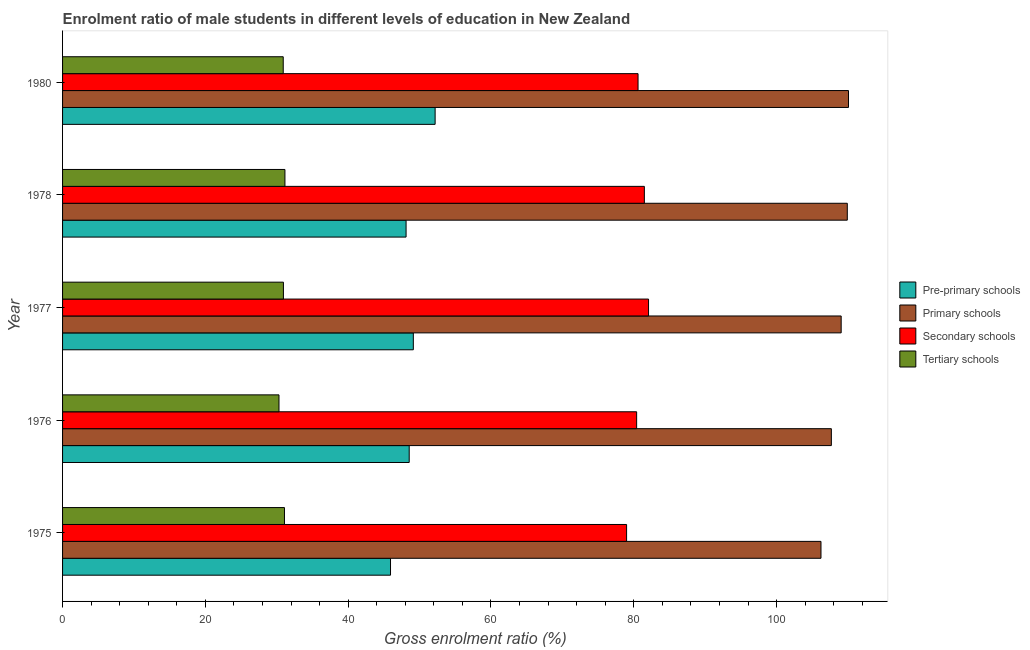How many different coloured bars are there?
Provide a short and direct response. 4. Are the number of bars per tick equal to the number of legend labels?
Make the answer very short. Yes. Are the number of bars on each tick of the Y-axis equal?
Provide a succinct answer. Yes. What is the label of the 2nd group of bars from the top?
Make the answer very short. 1978. In how many cases, is the number of bars for a given year not equal to the number of legend labels?
Keep it short and to the point. 0. What is the gross enrolment ratio(female) in secondary schools in 1976?
Provide a short and direct response. 80.4. Across all years, what is the maximum gross enrolment ratio(female) in tertiary schools?
Provide a short and direct response. 31.14. Across all years, what is the minimum gross enrolment ratio(female) in pre-primary schools?
Provide a succinct answer. 45.93. In which year was the gross enrolment ratio(female) in primary schools minimum?
Give a very brief answer. 1975. What is the total gross enrolment ratio(female) in tertiary schools in the graph?
Offer a very short reply. 154.37. What is the difference between the gross enrolment ratio(female) in tertiary schools in 1976 and that in 1977?
Your response must be concise. -0.62. What is the difference between the gross enrolment ratio(female) in primary schools in 1978 and the gross enrolment ratio(female) in tertiary schools in 1975?
Ensure brevity in your answer.  78.83. What is the average gross enrolment ratio(female) in secondary schools per year?
Give a very brief answer. 80.71. In the year 1977, what is the difference between the gross enrolment ratio(female) in pre-primary schools and gross enrolment ratio(female) in tertiary schools?
Provide a short and direct response. 18.19. Is the gross enrolment ratio(female) in secondary schools in 1977 less than that in 1978?
Your answer should be compact. No. Is the difference between the gross enrolment ratio(female) in tertiary schools in 1978 and 1980 greater than the difference between the gross enrolment ratio(female) in secondary schools in 1978 and 1980?
Offer a terse response. No. What is the difference between the highest and the second highest gross enrolment ratio(female) in pre-primary schools?
Keep it short and to the point. 3.05. What is the difference between the highest and the lowest gross enrolment ratio(female) in pre-primary schools?
Give a very brief answer. 6.25. What does the 1st bar from the top in 1980 represents?
Give a very brief answer. Tertiary schools. What does the 1st bar from the bottom in 1975 represents?
Offer a very short reply. Pre-primary schools. How many years are there in the graph?
Your answer should be very brief. 5. What is the difference between two consecutive major ticks on the X-axis?
Keep it short and to the point. 20. Are the values on the major ticks of X-axis written in scientific E-notation?
Your answer should be compact. No. Where does the legend appear in the graph?
Your response must be concise. Center right. What is the title of the graph?
Make the answer very short. Enrolment ratio of male students in different levels of education in New Zealand. Does "Social equity" appear as one of the legend labels in the graph?
Your answer should be compact. No. What is the label or title of the X-axis?
Provide a succinct answer. Gross enrolment ratio (%). What is the label or title of the Y-axis?
Provide a succinct answer. Year. What is the Gross enrolment ratio (%) in Pre-primary schools in 1975?
Offer a very short reply. 45.93. What is the Gross enrolment ratio (%) of Primary schools in 1975?
Provide a succinct answer. 106.22. What is the Gross enrolment ratio (%) of Secondary schools in 1975?
Provide a short and direct response. 79. What is the Gross enrolment ratio (%) of Tertiary schools in 1975?
Ensure brevity in your answer.  31.08. What is the Gross enrolment ratio (%) in Pre-primary schools in 1976?
Your answer should be very brief. 48.55. What is the Gross enrolment ratio (%) of Primary schools in 1976?
Keep it short and to the point. 107.68. What is the Gross enrolment ratio (%) in Secondary schools in 1976?
Give a very brief answer. 80.4. What is the Gross enrolment ratio (%) of Tertiary schools in 1976?
Offer a very short reply. 30.31. What is the Gross enrolment ratio (%) of Pre-primary schools in 1977?
Keep it short and to the point. 49.13. What is the Gross enrolment ratio (%) of Primary schools in 1977?
Offer a terse response. 109.05. What is the Gross enrolment ratio (%) of Secondary schools in 1977?
Offer a very short reply. 82.07. What is the Gross enrolment ratio (%) of Tertiary schools in 1977?
Ensure brevity in your answer.  30.93. What is the Gross enrolment ratio (%) of Pre-primary schools in 1978?
Offer a very short reply. 48.11. What is the Gross enrolment ratio (%) of Primary schools in 1978?
Offer a very short reply. 109.91. What is the Gross enrolment ratio (%) in Secondary schools in 1978?
Offer a terse response. 81.48. What is the Gross enrolment ratio (%) in Tertiary schools in 1978?
Offer a very short reply. 31.14. What is the Gross enrolment ratio (%) in Pre-primary schools in 1980?
Keep it short and to the point. 52.18. What is the Gross enrolment ratio (%) in Primary schools in 1980?
Keep it short and to the point. 110.08. What is the Gross enrolment ratio (%) in Secondary schools in 1980?
Make the answer very short. 80.6. What is the Gross enrolment ratio (%) in Tertiary schools in 1980?
Keep it short and to the point. 30.91. Across all years, what is the maximum Gross enrolment ratio (%) in Pre-primary schools?
Offer a very short reply. 52.18. Across all years, what is the maximum Gross enrolment ratio (%) of Primary schools?
Your response must be concise. 110.08. Across all years, what is the maximum Gross enrolment ratio (%) of Secondary schools?
Provide a succinct answer. 82.07. Across all years, what is the maximum Gross enrolment ratio (%) of Tertiary schools?
Ensure brevity in your answer.  31.14. Across all years, what is the minimum Gross enrolment ratio (%) of Pre-primary schools?
Your answer should be very brief. 45.93. Across all years, what is the minimum Gross enrolment ratio (%) of Primary schools?
Ensure brevity in your answer.  106.22. Across all years, what is the minimum Gross enrolment ratio (%) in Secondary schools?
Your response must be concise. 79. Across all years, what is the minimum Gross enrolment ratio (%) of Tertiary schools?
Keep it short and to the point. 30.31. What is the total Gross enrolment ratio (%) of Pre-primary schools in the graph?
Offer a terse response. 243.9. What is the total Gross enrolment ratio (%) of Primary schools in the graph?
Provide a short and direct response. 542.94. What is the total Gross enrolment ratio (%) in Secondary schools in the graph?
Ensure brevity in your answer.  403.56. What is the total Gross enrolment ratio (%) in Tertiary schools in the graph?
Your answer should be very brief. 154.37. What is the difference between the Gross enrolment ratio (%) of Pre-primary schools in 1975 and that in 1976?
Offer a very short reply. -2.62. What is the difference between the Gross enrolment ratio (%) of Primary schools in 1975 and that in 1976?
Give a very brief answer. -1.45. What is the difference between the Gross enrolment ratio (%) in Secondary schools in 1975 and that in 1976?
Provide a succinct answer. -1.41. What is the difference between the Gross enrolment ratio (%) in Tertiary schools in 1975 and that in 1976?
Ensure brevity in your answer.  0.77. What is the difference between the Gross enrolment ratio (%) in Pre-primary schools in 1975 and that in 1977?
Ensure brevity in your answer.  -3.19. What is the difference between the Gross enrolment ratio (%) of Primary schools in 1975 and that in 1977?
Your response must be concise. -2.83. What is the difference between the Gross enrolment ratio (%) of Secondary schools in 1975 and that in 1977?
Offer a terse response. -3.07. What is the difference between the Gross enrolment ratio (%) of Tertiary schools in 1975 and that in 1977?
Your answer should be very brief. 0.15. What is the difference between the Gross enrolment ratio (%) of Pre-primary schools in 1975 and that in 1978?
Give a very brief answer. -2.18. What is the difference between the Gross enrolment ratio (%) of Primary schools in 1975 and that in 1978?
Give a very brief answer. -3.69. What is the difference between the Gross enrolment ratio (%) in Secondary schools in 1975 and that in 1978?
Make the answer very short. -2.49. What is the difference between the Gross enrolment ratio (%) of Tertiary schools in 1975 and that in 1978?
Provide a short and direct response. -0.06. What is the difference between the Gross enrolment ratio (%) in Pre-primary schools in 1975 and that in 1980?
Offer a terse response. -6.25. What is the difference between the Gross enrolment ratio (%) in Primary schools in 1975 and that in 1980?
Provide a short and direct response. -3.85. What is the difference between the Gross enrolment ratio (%) of Secondary schools in 1975 and that in 1980?
Give a very brief answer. -1.6. What is the difference between the Gross enrolment ratio (%) of Tertiary schools in 1975 and that in 1980?
Ensure brevity in your answer.  0.17. What is the difference between the Gross enrolment ratio (%) of Pre-primary schools in 1976 and that in 1977?
Offer a terse response. -0.58. What is the difference between the Gross enrolment ratio (%) in Primary schools in 1976 and that in 1977?
Provide a succinct answer. -1.37. What is the difference between the Gross enrolment ratio (%) in Secondary schools in 1976 and that in 1977?
Offer a terse response. -1.67. What is the difference between the Gross enrolment ratio (%) of Tertiary schools in 1976 and that in 1977?
Give a very brief answer. -0.62. What is the difference between the Gross enrolment ratio (%) of Pre-primary schools in 1976 and that in 1978?
Keep it short and to the point. 0.44. What is the difference between the Gross enrolment ratio (%) of Primary schools in 1976 and that in 1978?
Your answer should be compact. -2.23. What is the difference between the Gross enrolment ratio (%) of Secondary schools in 1976 and that in 1978?
Your answer should be very brief. -1.08. What is the difference between the Gross enrolment ratio (%) of Tertiary schools in 1976 and that in 1978?
Ensure brevity in your answer.  -0.83. What is the difference between the Gross enrolment ratio (%) of Pre-primary schools in 1976 and that in 1980?
Keep it short and to the point. -3.63. What is the difference between the Gross enrolment ratio (%) of Primary schools in 1976 and that in 1980?
Offer a very short reply. -2.4. What is the difference between the Gross enrolment ratio (%) of Secondary schools in 1976 and that in 1980?
Provide a succinct answer. -0.2. What is the difference between the Gross enrolment ratio (%) in Tertiary schools in 1976 and that in 1980?
Provide a succinct answer. -0.6. What is the difference between the Gross enrolment ratio (%) in Pre-primary schools in 1977 and that in 1978?
Make the answer very short. 1.01. What is the difference between the Gross enrolment ratio (%) in Primary schools in 1977 and that in 1978?
Ensure brevity in your answer.  -0.86. What is the difference between the Gross enrolment ratio (%) in Secondary schools in 1977 and that in 1978?
Offer a terse response. 0.59. What is the difference between the Gross enrolment ratio (%) of Tertiary schools in 1977 and that in 1978?
Keep it short and to the point. -0.21. What is the difference between the Gross enrolment ratio (%) of Pre-primary schools in 1977 and that in 1980?
Offer a very short reply. -3.05. What is the difference between the Gross enrolment ratio (%) of Primary schools in 1977 and that in 1980?
Make the answer very short. -1.03. What is the difference between the Gross enrolment ratio (%) in Secondary schools in 1977 and that in 1980?
Make the answer very short. 1.47. What is the difference between the Gross enrolment ratio (%) in Tertiary schools in 1977 and that in 1980?
Offer a very short reply. 0.03. What is the difference between the Gross enrolment ratio (%) of Pre-primary schools in 1978 and that in 1980?
Ensure brevity in your answer.  -4.07. What is the difference between the Gross enrolment ratio (%) in Primary schools in 1978 and that in 1980?
Keep it short and to the point. -0.17. What is the difference between the Gross enrolment ratio (%) of Secondary schools in 1978 and that in 1980?
Make the answer very short. 0.88. What is the difference between the Gross enrolment ratio (%) of Tertiary schools in 1978 and that in 1980?
Offer a terse response. 0.24. What is the difference between the Gross enrolment ratio (%) of Pre-primary schools in 1975 and the Gross enrolment ratio (%) of Primary schools in 1976?
Ensure brevity in your answer.  -61.75. What is the difference between the Gross enrolment ratio (%) in Pre-primary schools in 1975 and the Gross enrolment ratio (%) in Secondary schools in 1976?
Your answer should be very brief. -34.47. What is the difference between the Gross enrolment ratio (%) in Pre-primary schools in 1975 and the Gross enrolment ratio (%) in Tertiary schools in 1976?
Your response must be concise. 15.62. What is the difference between the Gross enrolment ratio (%) of Primary schools in 1975 and the Gross enrolment ratio (%) of Secondary schools in 1976?
Your answer should be compact. 25.82. What is the difference between the Gross enrolment ratio (%) of Primary schools in 1975 and the Gross enrolment ratio (%) of Tertiary schools in 1976?
Give a very brief answer. 75.91. What is the difference between the Gross enrolment ratio (%) of Secondary schools in 1975 and the Gross enrolment ratio (%) of Tertiary schools in 1976?
Offer a terse response. 48.69. What is the difference between the Gross enrolment ratio (%) in Pre-primary schools in 1975 and the Gross enrolment ratio (%) in Primary schools in 1977?
Provide a short and direct response. -63.12. What is the difference between the Gross enrolment ratio (%) in Pre-primary schools in 1975 and the Gross enrolment ratio (%) in Secondary schools in 1977?
Keep it short and to the point. -36.14. What is the difference between the Gross enrolment ratio (%) of Pre-primary schools in 1975 and the Gross enrolment ratio (%) of Tertiary schools in 1977?
Offer a very short reply. 15. What is the difference between the Gross enrolment ratio (%) of Primary schools in 1975 and the Gross enrolment ratio (%) of Secondary schools in 1977?
Your answer should be compact. 24.15. What is the difference between the Gross enrolment ratio (%) in Primary schools in 1975 and the Gross enrolment ratio (%) in Tertiary schools in 1977?
Make the answer very short. 75.29. What is the difference between the Gross enrolment ratio (%) in Secondary schools in 1975 and the Gross enrolment ratio (%) in Tertiary schools in 1977?
Your answer should be compact. 48.07. What is the difference between the Gross enrolment ratio (%) in Pre-primary schools in 1975 and the Gross enrolment ratio (%) in Primary schools in 1978?
Your response must be concise. -63.98. What is the difference between the Gross enrolment ratio (%) of Pre-primary schools in 1975 and the Gross enrolment ratio (%) of Secondary schools in 1978?
Offer a terse response. -35.55. What is the difference between the Gross enrolment ratio (%) of Pre-primary schools in 1975 and the Gross enrolment ratio (%) of Tertiary schools in 1978?
Keep it short and to the point. 14.79. What is the difference between the Gross enrolment ratio (%) in Primary schools in 1975 and the Gross enrolment ratio (%) in Secondary schools in 1978?
Ensure brevity in your answer.  24.74. What is the difference between the Gross enrolment ratio (%) of Primary schools in 1975 and the Gross enrolment ratio (%) of Tertiary schools in 1978?
Provide a succinct answer. 75.08. What is the difference between the Gross enrolment ratio (%) in Secondary schools in 1975 and the Gross enrolment ratio (%) in Tertiary schools in 1978?
Offer a terse response. 47.85. What is the difference between the Gross enrolment ratio (%) in Pre-primary schools in 1975 and the Gross enrolment ratio (%) in Primary schools in 1980?
Your answer should be very brief. -64.15. What is the difference between the Gross enrolment ratio (%) in Pre-primary schools in 1975 and the Gross enrolment ratio (%) in Secondary schools in 1980?
Give a very brief answer. -34.67. What is the difference between the Gross enrolment ratio (%) in Pre-primary schools in 1975 and the Gross enrolment ratio (%) in Tertiary schools in 1980?
Your response must be concise. 15.02. What is the difference between the Gross enrolment ratio (%) in Primary schools in 1975 and the Gross enrolment ratio (%) in Secondary schools in 1980?
Make the answer very short. 25.62. What is the difference between the Gross enrolment ratio (%) in Primary schools in 1975 and the Gross enrolment ratio (%) in Tertiary schools in 1980?
Your answer should be very brief. 75.32. What is the difference between the Gross enrolment ratio (%) in Secondary schools in 1975 and the Gross enrolment ratio (%) in Tertiary schools in 1980?
Offer a terse response. 48.09. What is the difference between the Gross enrolment ratio (%) of Pre-primary schools in 1976 and the Gross enrolment ratio (%) of Primary schools in 1977?
Ensure brevity in your answer.  -60.5. What is the difference between the Gross enrolment ratio (%) in Pre-primary schools in 1976 and the Gross enrolment ratio (%) in Secondary schools in 1977?
Offer a very short reply. -33.52. What is the difference between the Gross enrolment ratio (%) of Pre-primary schools in 1976 and the Gross enrolment ratio (%) of Tertiary schools in 1977?
Your response must be concise. 17.62. What is the difference between the Gross enrolment ratio (%) in Primary schools in 1976 and the Gross enrolment ratio (%) in Secondary schools in 1977?
Provide a succinct answer. 25.61. What is the difference between the Gross enrolment ratio (%) in Primary schools in 1976 and the Gross enrolment ratio (%) in Tertiary schools in 1977?
Your answer should be very brief. 76.74. What is the difference between the Gross enrolment ratio (%) of Secondary schools in 1976 and the Gross enrolment ratio (%) of Tertiary schools in 1977?
Your answer should be compact. 49.47. What is the difference between the Gross enrolment ratio (%) in Pre-primary schools in 1976 and the Gross enrolment ratio (%) in Primary schools in 1978?
Provide a short and direct response. -61.36. What is the difference between the Gross enrolment ratio (%) of Pre-primary schools in 1976 and the Gross enrolment ratio (%) of Secondary schools in 1978?
Your answer should be compact. -32.93. What is the difference between the Gross enrolment ratio (%) in Pre-primary schools in 1976 and the Gross enrolment ratio (%) in Tertiary schools in 1978?
Keep it short and to the point. 17.41. What is the difference between the Gross enrolment ratio (%) in Primary schools in 1976 and the Gross enrolment ratio (%) in Secondary schools in 1978?
Your answer should be compact. 26.19. What is the difference between the Gross enrolment ratio (%) in Primary schools in 1976 and the Gross enrolment ratio (%) in Tertiary schools in 1978?
Keep it short and to the point. 76.53. What is the difference between the Gross enrolment ratio (%) of Secondary schools in 1976 and the Gross enrolment ratio (%) of Tertiary schools in 1978?
Provide a succinct answer. 49.26. What is the difference between the Gross enrolment ratio (%) of Pre-primary schools in 1976 and the Gross enrolment ratio (%) of Primary schools in 1980?
Your answer should be compact. -61.53. What is the difference between the Gross enrolment ratio (%) of Pre-primary schools in 1976 and the Gross enrolment ratio (%) of Secondary schools in 1980?
Ensure brevity in your answer.  -32.05. What is the difference between the Gross enrolment ratio (%) in Pre-primary schools in 1976 and the Gross enrolment ratio (%) in Tertiary schools in 1980?
Provide a short and direct response. 17.64. What is the difference between the Gross enrolment ratio (%) of Primary schools in 1976 and the Gross enrolment ratio (%) of Secondary schools in 1980?
Offer a very short reply. 27.08. What is the difference between the Gross enrolment ratio (%) of Primary schools in 1976 and the Gross enrolment ratio (%) of Tertiary schools in 1980?
Your answer should be very brief. 76.77. What is the difference between the Gross enrolment ratio (%) of Secondary schools in 1976 and the Gross enrolment ratio (%) of Tertiary schools in 1980?
Provide a succinct answer. 49.5. What is the difference between the Gross enrolment ratio (%) in Pre-primary schools in 1977 and the Gross enrolment ratio (%) in Primary schools in 1978?
Offer a terse response. -60.78. What is the difference between the Gross enrolment ratio (%) of Pre-primary schools in 1977 and the Gross enrolment ratio (%) of Secondary schools in 1978?
Your response must be concise. -32.36. What is the difference between the Gross enrolment ratio (%) in Pre-primary schools in 1977 and the Gross enrolment ratio (%) in Tertiary schools in 1978?
Provide a short and direct response. 17.98. What is the difference between the Gross enrolment ratio (%) in Primary schools in 1977 and the Gross enrolment ratio (%) in Secondary schools in 1978?
Your answer should be compact. 27.57. What is the difference between the Gross enrolment ratio (%) of Primary schools in 1977 and the Gross enrolment ratio (%) of Tertiary schools in 1978?
Your response must be concise. 77.91. What is the difference between the Gross enrolment ratio (%) in Secondary schools in 1977 and the Gross enrolment ratio (%) in Tertiary schools in 1978?
Your answer should be compact. 50.93. What is the difference between the Gross enrolment ratio (%) of Pre-primary schools in 1977 and the Gross enrolment ratio (%) of Primary schools in 1980?
Make the answer very short. -60.95. What is the difference between the Gross enrolment ratio (%) of Pre-primary schools in 1977 and the Gross enrolment ratio (%) of Secondary schools in 1980?
Your answer should be compact. -31.47. What is the difference between the Gross enrolment ratio (%) in Pre-primary schools in 1977 and the Gross enrolment ratio (%) in Tertiary schools in 1980?
Your response must be concise. 18.22. What is the difference between the Gross enrolment ratio (%) in Primary schools in 1977 and the Gross enrolment ratio (%) in Secondary schools in 1980?
Keep it short and to the point. 28.45. What is the difference between the Gross enrolment ratio (%) in Primary schools in 1977 and the Gross enrolment ratio (%) in Tertiary schools in 1980?
Provide a succinct answer. 78.14. What is the difference between the Gross enrolment ratio (%) in Secondary schools in 1977 and the Gross enrolment ratio (%) in Tertiary schools in 1980?
Provide a short and direct response. 51.16. What is the difference between the Gross enrolment ratio (%) in Pre-primary schools in 1978 and the Gross enrolment ratio (%) in Primary schools in 1980?
Your response must be concise. -61.97. What is the difference between the Gross enrolment ratio (%) in Pre-primary schools in 1978 and the Gross enrolment ratio (%) in Secondary schools in 1980?
Offer a very short reply. -32.49. What is the difference between the Gross enrolment ratio (%) in Pre-primary schools in 1978 and the Gross enrolment ratio (%) in Tertiary schools in 1980?
Offer a very short reply. 17.21. What is the difference between the Gross enrolment ratio (%) in Primary schools in 1978 and the Gross enrolment ratio (%) in Secondary schools in 1980?
Your answer should be very brief. 29.31. What is the difference between the Gross enrolment ratio (%) of Primary schools in 1978 and the Gross enrolment ratio (%) of Tertiary schools in 1980?
Your answer should be compact. 79. What is the difference between the Gross enrolment ratio (%) in Secondary schools in 1978 and the Gross enrolment ratio (%) in Tertiary schools in 1980?
Ensure brevity in your answer.  50.58. What is the average Gross enrolment ratio (%) in Pre-primary schools per year?
Your answer should be very brief. 48.78. What is the average Gross enrolment ratio (%) of Primary schools per year?
Make the answer very short. 108.59. What is the average Gross enrolment ratio (%) in Secondary schools per year?
Offer a very short reply. 80.71. What is the average Gross enrolment ratio (%) in Tertiary schools per year?
Your answer should be compact. 30.87. In the year 1975, what is the difference between the Gross enrolment ratio (%) of Pre-primary schools and Gross enrolment ratio (%) of Primary schools?
Offer a very short reply. -60.29. In the year 1975, what is the difference between the Gross enrolment ratio (%) in Pre-primary schools and Gross enrolment ratio (%) in Secondary schools?
Keep it short and to the point. -33.07. In the year 1975, what is the difference between the Gross enrolment ratio (%) in Pre-primary schools and Gross enrolment ratio (%) in Tertiary schools?
Provide a short and direct response. 14.85. In the year 1975, what is the difference between the Gross enrolment ratio (%) of Primary schools and Gross enrolment ratio (%) of Secondary schools?
Keep it short and to the point. 27.23. In the year 1975, what is the difference between the Gross enrolment ratio (%) of Primary schools and Gross enrolment ratio (%) of Tertiary schools?
Offer a terse response. 75.14. In the year 1975, what is the difference between the Gross enrolment ratio (%) of Secondary schools and Gross enrolment ratio (%) of Tertiary schools?
Your answer should be very brief. 47.92. In the year 1976, what is the difference between the Gross enrolment ratio (%) of Pre-primary schools and Gross enrolment ratio (%) of Primary schools?
Make the answer very short. -59.13. In the year 1976, what is the difference between the Gross enrolment ratio (%) of Pre-primary schools and Gross enrolment ratio (%) of Secondary schools?
Your answer should be compact. -31.85. In the year 1976, what is the difference between the Gross enrolment ratio (%) in Pre-primary schools and Gross enrolment ratio (%) in Tertiary schools?
Provide a short and direct response. 18.24. In the year 1976, what is the difference between the Gross enrolment ratio (%) in Primary schools and Gross enrolment ratio (%) in Secondary schools?
Your response must be concise. 27.27. In the year 1976, what is the difference between the Gross enrolment ratio (%) of Primary schools and Gross enrolment ratio (%) of Tertiary schools?
Ensure brevity in your answer.  77.37. In the year 1976, what is the difference between the Gross enrolment ratio (%) in Secondary schools and Gross enrolment ratio (%) in Tertiary schools?
Your answer should be compact. 50.09. In the year 1977, what is the difference between the Gross enrolment ratio (%) of Pre-primary schools and Gross enrolment ratio (%) of Primary schools?
Your answer should be compact. -59.92. In the year 1977, what is the difference between the Gross enrolment ratio (%) of Pre-primary schools and Gross enrolment ratio (%) of Secondary schools?
Make the answer very short. -32.95. In the year 1977, what is the difference between the Gross enrolment ratio (%) in Pre-primary schools and Gross enrolment ratio (%) in Tertiary schools?
Your answer should be compact. 18.19. In the year 1977, what is the difference between the Gross enrolment ratio (%) of Primary schools and Gross enrolment ratio (%) of Secondary schools?
Your response must be concise. 26.98. In the year 1977, what is the difference between the Gross enrolment ratio (%) of Primary schools and Gross enrolment ratio (%) of Tertiary schools?
Your answer should be very brief. 78.12. In the year 1977, what is the difference between the Gross enrolment ratio (%) in Secondary schools and Gross enrolment ratio (%) in Tertiary schools?
Your response must be concise. 51.14. In the year 1978, what is the difference between the Gross enrolment ratio (%) of Pre-primary schools and Gross enrolment ratio (%) of Primary schools?
Your answer should be very brief. -61.8. In the year 1978, what is the difference between the Gross enrolment ratio (%) in Pre-primary schools and Gross enrolment ratio (%) in Secondary schools?
Offer a very short reply. -33.37. In the year 1978, what is the difference between the Gross enrolment ratio (%) in Pre-primary schools and Gross enrolment ratio (%) in Tertiary schools?
Your answer should be very brief. 16.97. In the year 1978, what is the difference between the Gross enrolment ratio (%) in Primary schools and Gross enrolment ratio (%) in Secondary schools?
Your answer should be compact. 28.42. In the year 1978, what is the difference between the Gross enrolment ratio (%) in Primary schools and Gross enrolment ratio (%) in Tertiary schools?
Offer a terse response. 78.76. In the year 1978, what is the difference between the Gross enrolment ratio (%) of Secondary schools and Gross enrolment ratio (%) of Tertiary schools?
Make the answer very short. 50.34. In the year 1980, what is the difference between the Gross enrolment ratio (%) of Pre-primary schools and Gross enrolment ratio (%) of Primary schools?
Your answer should be very brief. -57.9. In the year 1980, what is the difference between the Gross enrolment ratio (%) of Pre-primary schools and Gross enrolment ratio (%) of Secondary schools?
Make the answer very short. -28.42. In the year 1980, what is the difference between the Gross enrolment ratio (%) of Pre-primary schools and Gross enrolment ratio (%) of Tertiary schools?
Make the answer very short. 21.27. In the year 1980, what is the difference between the Gross enrolment ratio (%) in Primary schools and Gross enrolment ratio (%) in Secondary schools?
Your answer should be compact. 29.48. In the year 1980, what is the difference between the Gross enrolment ratio (%) in Primary schools and Gross enrolment ratio (%) in Tertiary schools?
Your answer should be very brief. 79.17. In the year 1980, what is the difference between the Gross enrolment ratio (%) in Secondary schools and Gross enrolment ratio (%) in Tertiary schools?
Your answer should be very brief. 49.69. What is the ratio of the Gross enrolment ratio (%) of Pre-primary schools in 1975 to that in 1976?
Your answer should be compact. 0.95. What is the ratio of the Gross enrolment ratio (%) in Primary schools in 1975 to that in 1976?
Provide a short and direct response. 0.99. What is the ratio of the Gross enrolment ratio (%) of Secondary schools in 1975 to that in 1976?
Your answer should be very brief. 0.98. What is the ratio of the Gross enrolment ratio (%) in Tertiary schools in 1975 to that in 1976?
Give a very brief answer. 1.03. What is the ratio of the Gross enrolment ratio (%) in Pre-primary schools in 1975 to that in 1977?
Your response must be concise. 0.94. What is the ratio of the Gross enrolment ratio (%) in Primary schools in 1975 to that in 1977?
Your response must be concise. 0.97. What is the ratio of the Gross enrolment ratio (%) of Secondary schools in 1975 to that in 1977?
Provide a short and direct response. 0.96. What is the ratio of the Gross enrolment ratio (%) in Tertiary schools in 1975 to that in 1977?
Ensure brevity in your answer.  1. What is the ratio of the Gross enrolment ratio (%) in Pre-primary schools in 1975 to that in 1978?
Your answer should be very brief. 0.95. What is the ratio of the Gross enrolment ratio (%) of Primary schools in 1975 to that in 1978?
Offer a terse response. 0.97. What is the ratio of the Gross enrolment ratio (%) in Secondary schools in 1975 to that in 1978?
Your response must be concise. 0.97. What is the ratio of the Gross enrolment ratio (%) of Pre-primary schools in 1975 to that in 1980?
Give a very brief answer. 0.88. What is the ratio of the Gross enrolment ratio (%) of Secondary schools in 1975 to that in 1980?
Offer a very short reply. 0.98. What is the ratio of the Gross enrolment ratio (%) of Tertiary schools in 1975 to that in 1980?
Provide a succinct answer. 1.01. What is the ratio of the Gross enrolment ratio (%) of Pre-primary schools in 1976 to that in 1977?
Provide a succinct answer. 0.99. What is the ratio of the Gross enrolment ratio (%) in Primary schools in 1976 to that in 1977?
Offer a very short reply. 0.99. What is the ratio of the Gross enrolment ratio (%) of Secondary schools in 1976 to that in 1977?
Your answer should be compact. 0.98. What is the ratio of the Gross enrolment ratio (%) in Tertiary schools in 1976 to that in 1977?
Give a very brief answer. 0.98. What is the ratio of the Gross enrolment ratio (%) in Pre-primary schools in 1976 to that in 1978?
Your answer should be very brief. 1.01. What is the ratio of the Gross enrolment ratio (%) in Primary schools in 1976 to that in 1978?
Give a very brief answer. 0.98. What is the ratio of the Gross enrolment ratio (%) in Secondary schools in 1976 to that in 1978?
Your answer should be very brief. 0.99. What is the ratio of the Gross enrolment ratio (%) in Tertiary schools in 1976 to that in 1978?
Keep it short and to the point. 0.97. What is the ratio of the Gross enrolment ratio (%) of Pre-primary schools in 1976 to that in 1980?
Keep it short and to the point. 0.93. What is the ratio of the Gross enrolment ratio (%) of Primary schools in 1976 to that in 1980?
Provide a short and direct response. 0.98. What is the ratio of the Gross enrolment ratio (%) of Secondary schools in 1976 to that in 1980?
Make the answer very short. 1. What is the ratio of the Gross enrolment ratio (%) in Tertiary schools in 1976 to that in 1980?
Provide a succinct answer. 0.98. What is the ratio of the Gross enrolment ratio (%) of Pre-primary schools in 1977 to that in 1978?
Provide a succinct answer. 1.02. What is the ratio of the Gross enrolment ratio (%) of Primary schools in 1977 to that in 1978?
Ensure brevity in your answer.  0.99. What is the ratio of the Gross enrolment ratio (%) in Secondary schools in 1977 to that in 1978?
Offer a very short reply. 1.01. What is the ratio of the Gross enrolment ratio (%) of Tertiary schools in 1977 to that in 1978?
Make the answer very short. 0.99. What is the ratio of the Gross enrolment ratio (%) in Pre-primary schools in 1977 to that in 1980?
Ensure brevity in your answer.  0.94. What is the ratio of the Gross enrolment ratio (%) of Secondary schools in 1977 to that in 1980?
Ensure brevity in your answer.  1.02. What is the ratio of the Gross enrolment ratio (%) in Pre-primary schools in 1978 to that in 1980?
Give a very brief answer. 0.92. What is the ratio of the Gross enrolment ratio (%) in Primary schools in 1978 to that in 1980?
Your response must be concise. 1. What is the ratio of the Gross enrolment ratio (%) of Tertiary schools in 1978 to that in 1980?
Offer a very short reply. 1.01. What is the difference between the highest and the second highest Gross enrolment ratio (%) of Pre-primary schools?
Offer a very short reply. 3.05. What is the difference between the highest and the second highest Gross enrolment ratio (%) of Primary schools?
Your answer should be compact. 0.17. What is the difference between the highest and the second highest Gross enrolment ratio (%) of Secondary schools?
Offer a very short reply. 0.59. What is the difference between the highest and the second highest Gross enrolment ratio (%) in Tertiary schools?
Your answer should be compact. 0.06. What is the difference between the highest and the lowest Gross enrolment ratio (%) in Pre-primary schools?
Your answer should be very brief. 6.25. What is the difference between the highest and the lowest Gross enrolment ratio (%) in Primary schools?
Keep it short and to the point. 3.85. What is the difference between the highest and the lowest Gross enrolment ratio (%) of Secondary schools?
Your answer should be very brief. 3.07. What is the difference between the highest and the lowest Gross enrolment ratio (%) in Tertiary schools?
Keep it short and to the point. 0.83. 